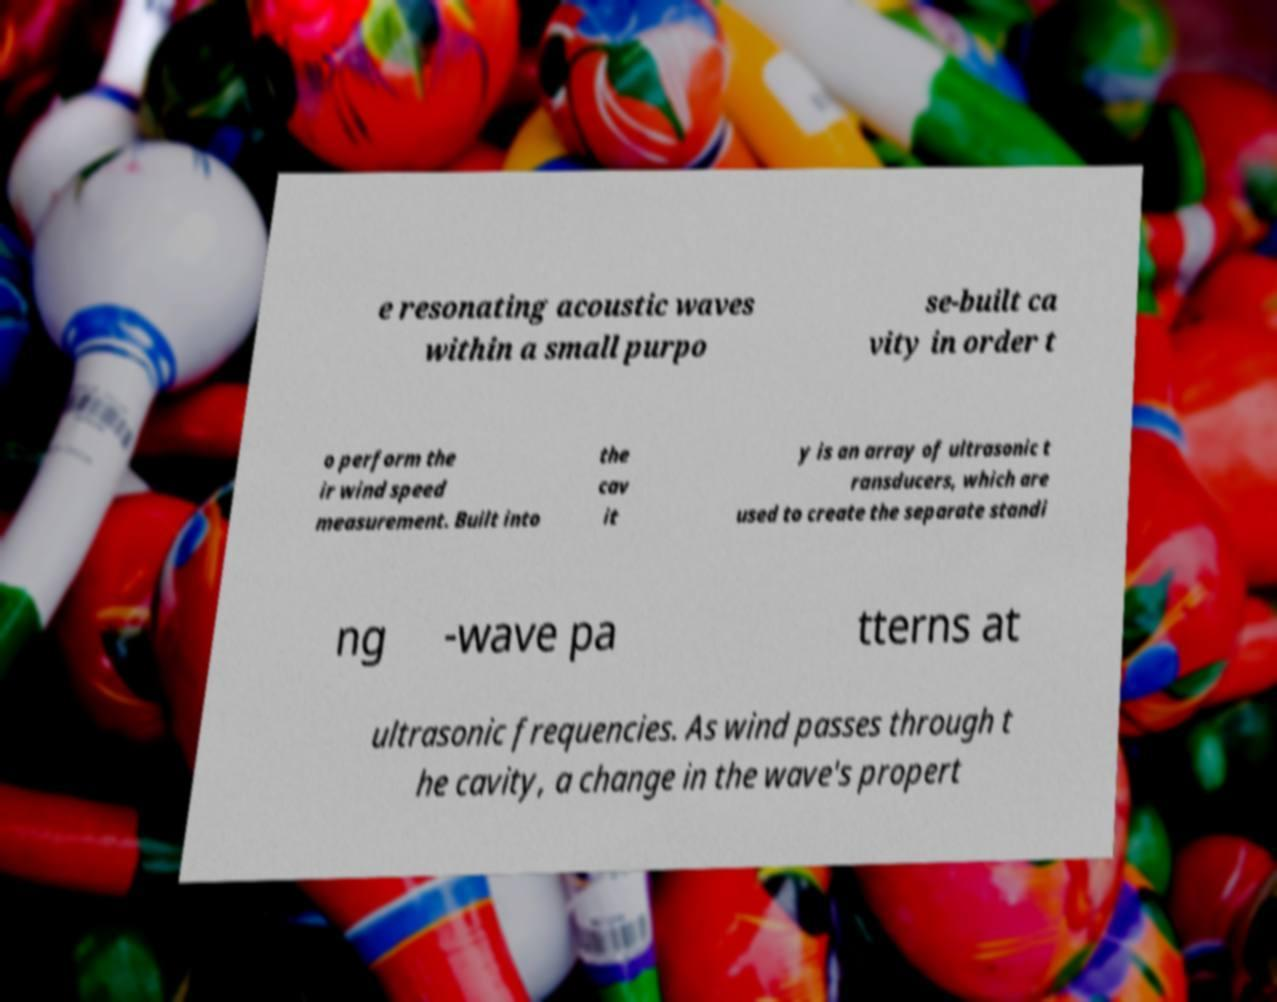Could you assist in decoding the text presented in this image and type it out clearly? e resonating acoustic waves within a small purpo se-built ca vity in order t o perform the ir wind speed measurement. Built into the cav it y is an array of ultrasonic t ransducers, which are used to create the separate standi ng -wave pa tterns at ultrasonic frequencies. As wind passes through t he cavity, a change in the wave's propert 